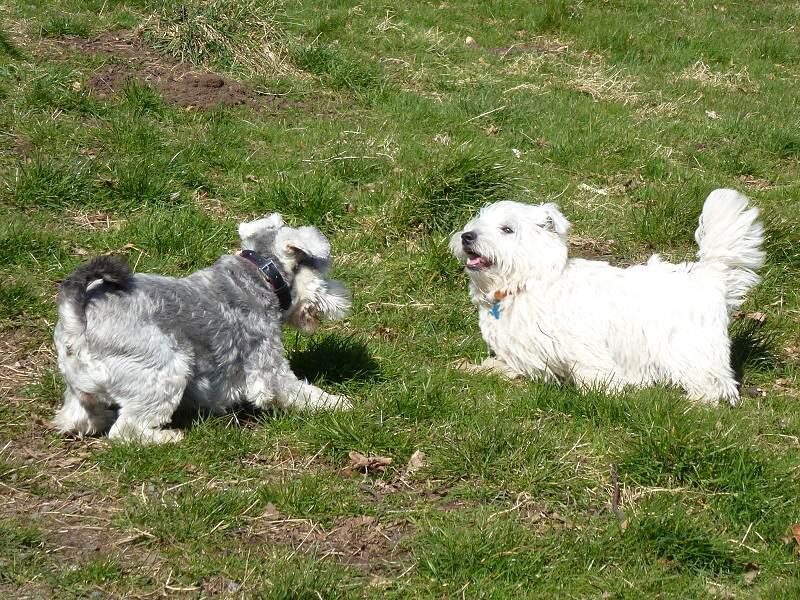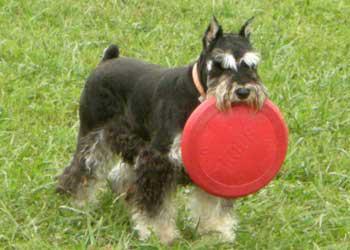The first image is the image on the left, the second image is the image on the right. Evaluate the accuracy of this statement regarding the images: "There is exactly one dog holding a toy in its mouth.". Is it true? Answer yes or no. Yes. The first image is the image on the left, the second image is the image on the right. Considering the images on both sides, is "The left image shows a grayer dog to the left of a whiter dog, and the right image shows at least one schnauzer with something held in its mouth." valid? Answer yes or no. Yes. 